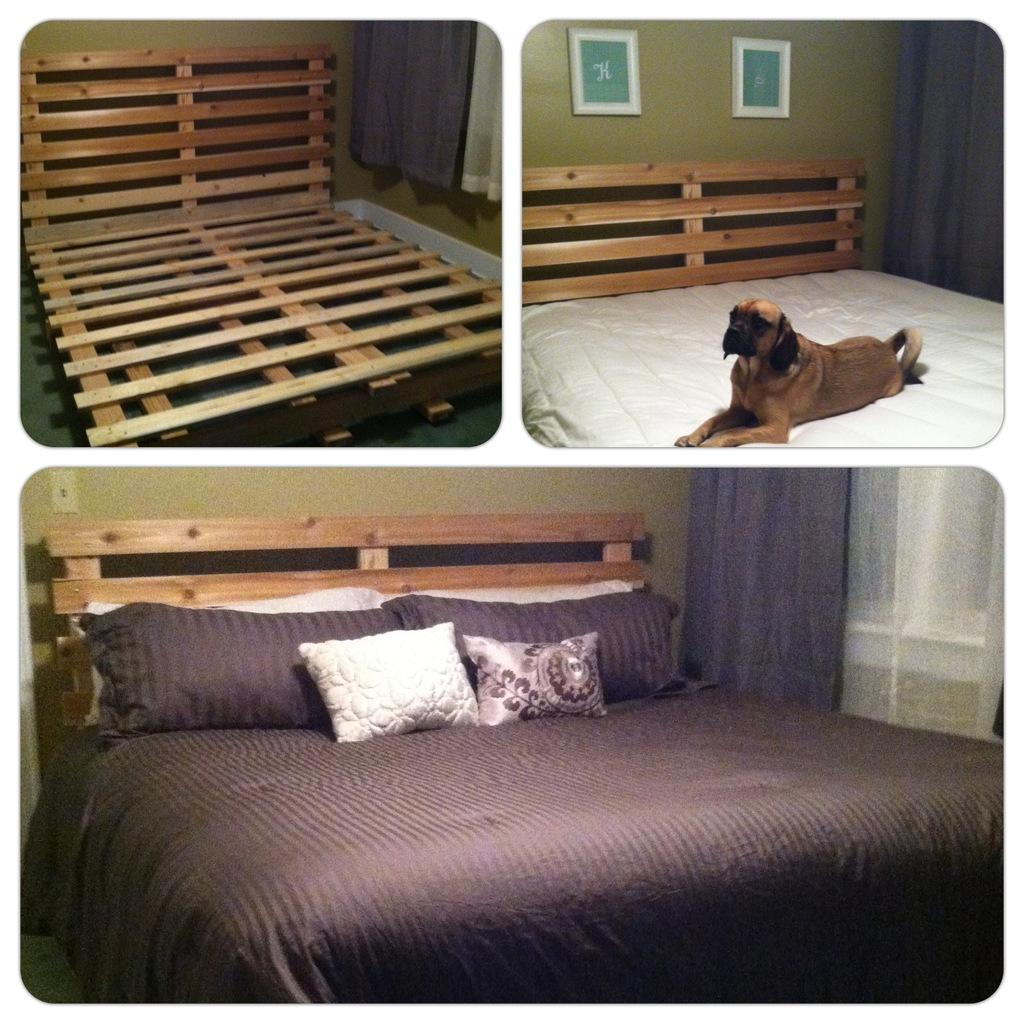What type of furniture is in the image? There is a wooden bed in the image. What is sitting on the bed? A dog is sitting on the bed. What covers the bed in the image? The bed has a bed sheet. What else is on the bed besides the dog and bed sheet? The bed has pillows. What type of fruit is hanging from the bed in the image? There is no fruit hanging from the bed in the image. Is there a light bulb attached to the dog in the image? There is: There is no light bulb or any electrical component visible in the image. 